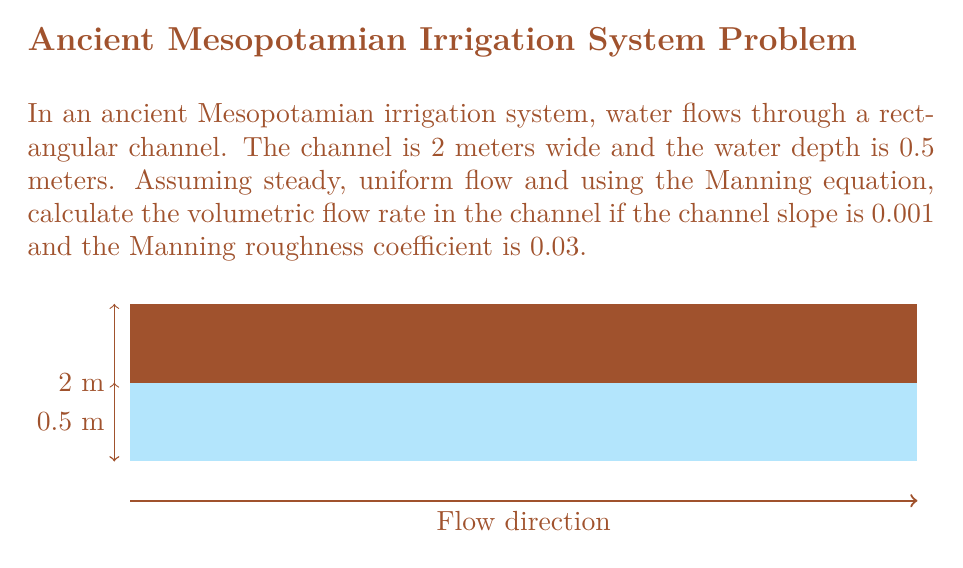Can you solve this math problem? To solve this problem, we'll use the Manning equation for open channel flow:

$$ Q = \frac{1}{n} A R^{2/3} S^{1/2} $$

Where:
$Q$ = volumetric flow rate (m³/s)
$n$ = Manning roughness coefficient
$A$ = cross-sectional area of flow (m²)
$R$ = hydraulic radius (m)
$S$ = channel slope

Step 1: Calculate the cross-sectional area (A)
$$ A = \text{width} \times \text{depth} = 2 \text{ m} \times 0.5 \text{ m} = 1 \text{ m}^2 $$

Step 2: Calculate the wetted perimeter (P)
$$ P = \text{width} + 2 \times \text{depth} = 2 \text{ m} + 2 \times 0.5 \text{ m} = 3 \text{ m} $$

Step 3: Calculate the hydraulic radius (R)
$$ R = \frac{A}{P} = \frac{1 \text{ m}^2}{3 \text{ m}} = 0.333 \text{ m} $$

Step 4: Apply the Manning equation
$$ Q = \frac{1}{0.03} \times 1 \text{ m}^2 \times (0.333 \text{ m})^{2/3} \times (0.001)^{1/2} $$

Step 5: Calculate the result
$$ Q = 33.33 \times 0.481 \times 0.0316 = 0.506 \text{ m}^3/\text{s} $$
Answer: 0.506 m³/s 